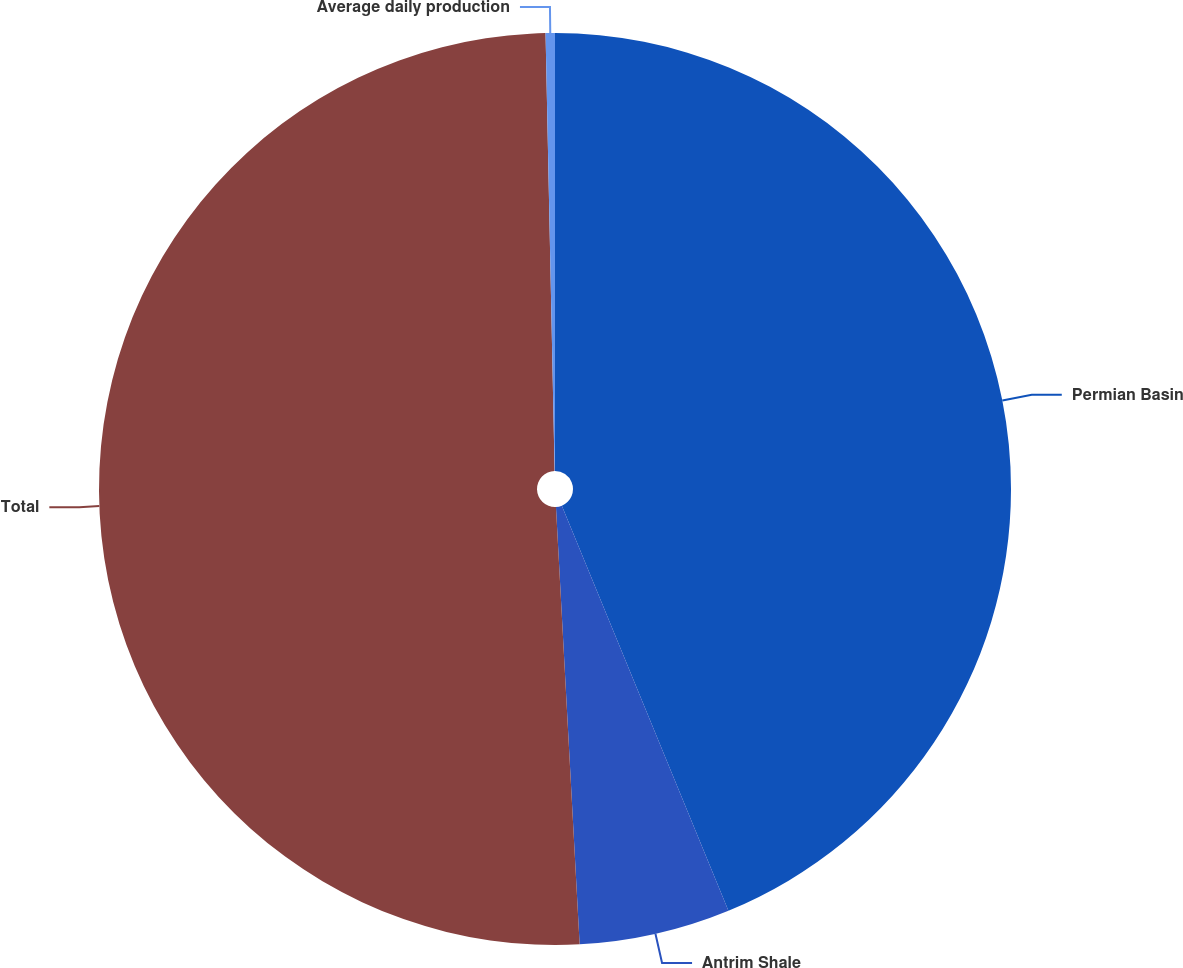Convert chart to OTSL. <chart><loc_0><loc_0><loc_500><loc_500><pie_chart><fcel>Permian Basin<fcel>Antrim Shale<fcel>Total<fcel>Average daily production<nl><fcel>43.79%<fcel>5.35%<fcel>50.53%<fcel>0.33%<nl></chart> 